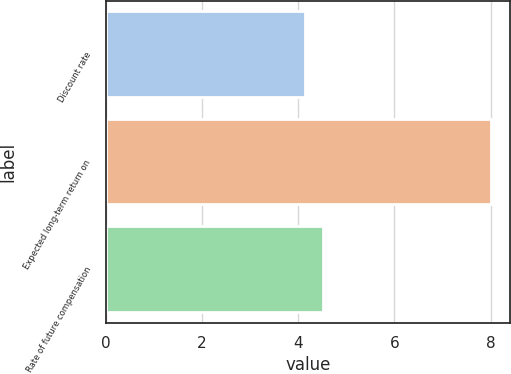<chart> <loc_0><loc_0><loc_500><loc_500><bar_chart><fcel>Discount rate<fcel>Expected long-term return on<fcel>Rate of future compensation<nl><fcel>4.13<fcel>8<fcel>4.52<nl></chart> 